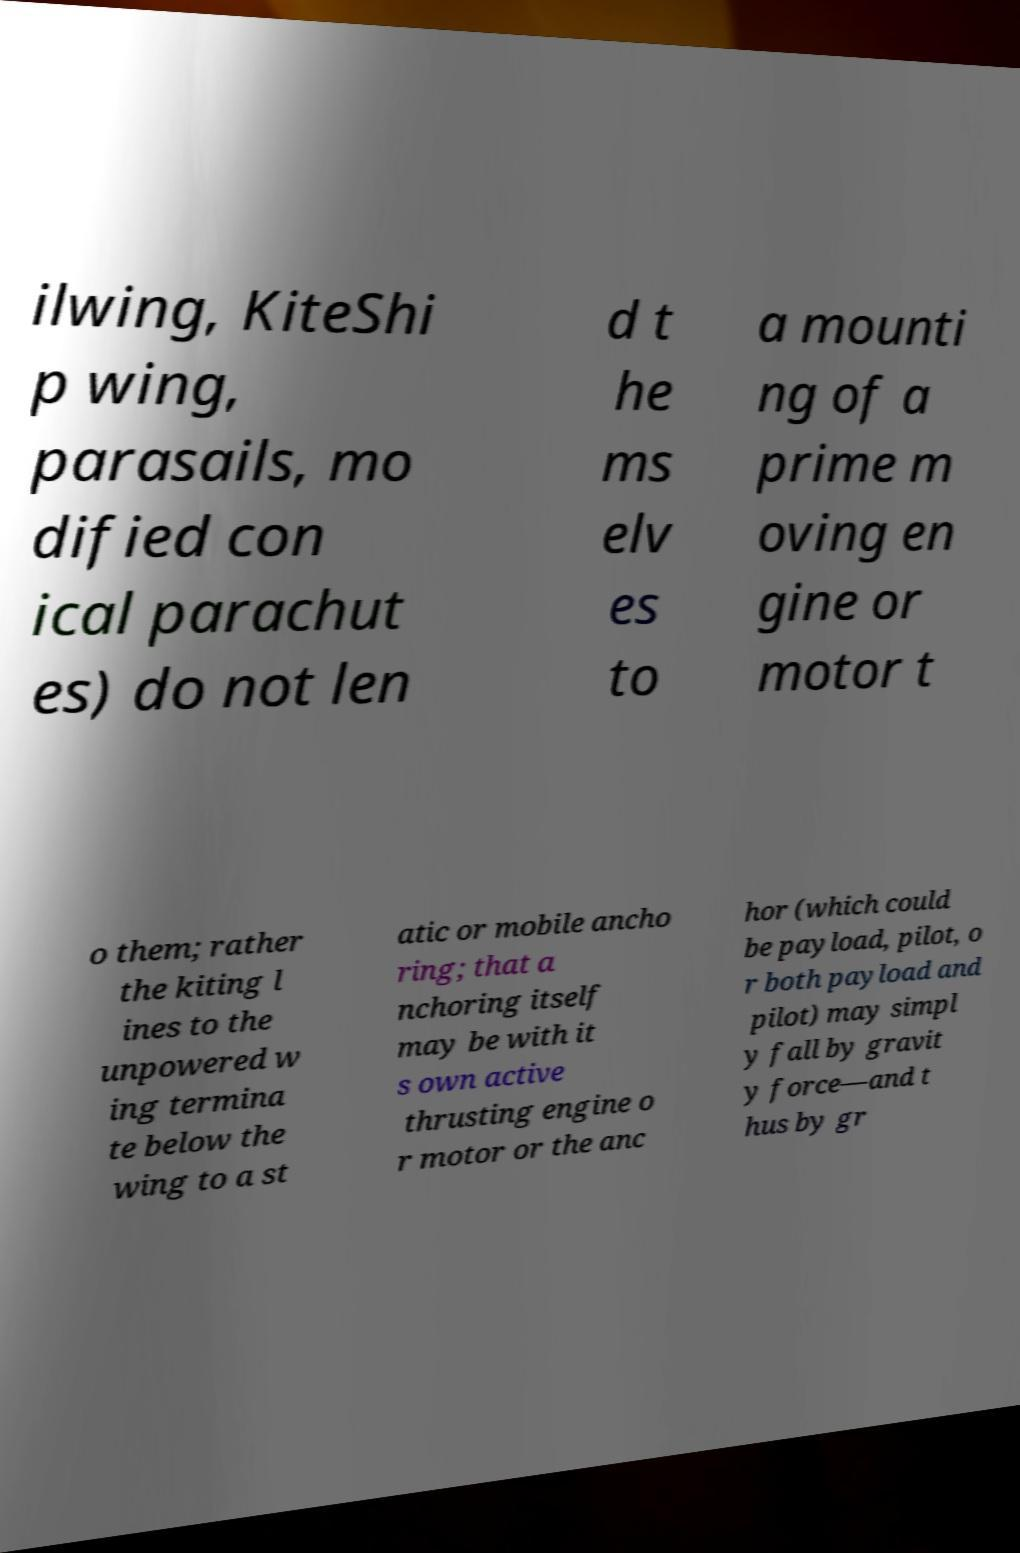Please read and relay the text visible in this image. What does it say? ilwing, KiteShi p wing, parasails, mo dified con ical parachut es) do not len d t he ms elv es to a mounti ng of a prime m oving en gine or motor t o them; rather the kiting l ines to the unpowered w ing termina te below the wing to a st atic or mobile ancho ring; that a nchoring itself may be with it s own active thrusting engine o r motor or the anc hor (which could be payload, pilot, o r both payload and pilot) may simpl y fall by gravit y force—and t hus by gr 